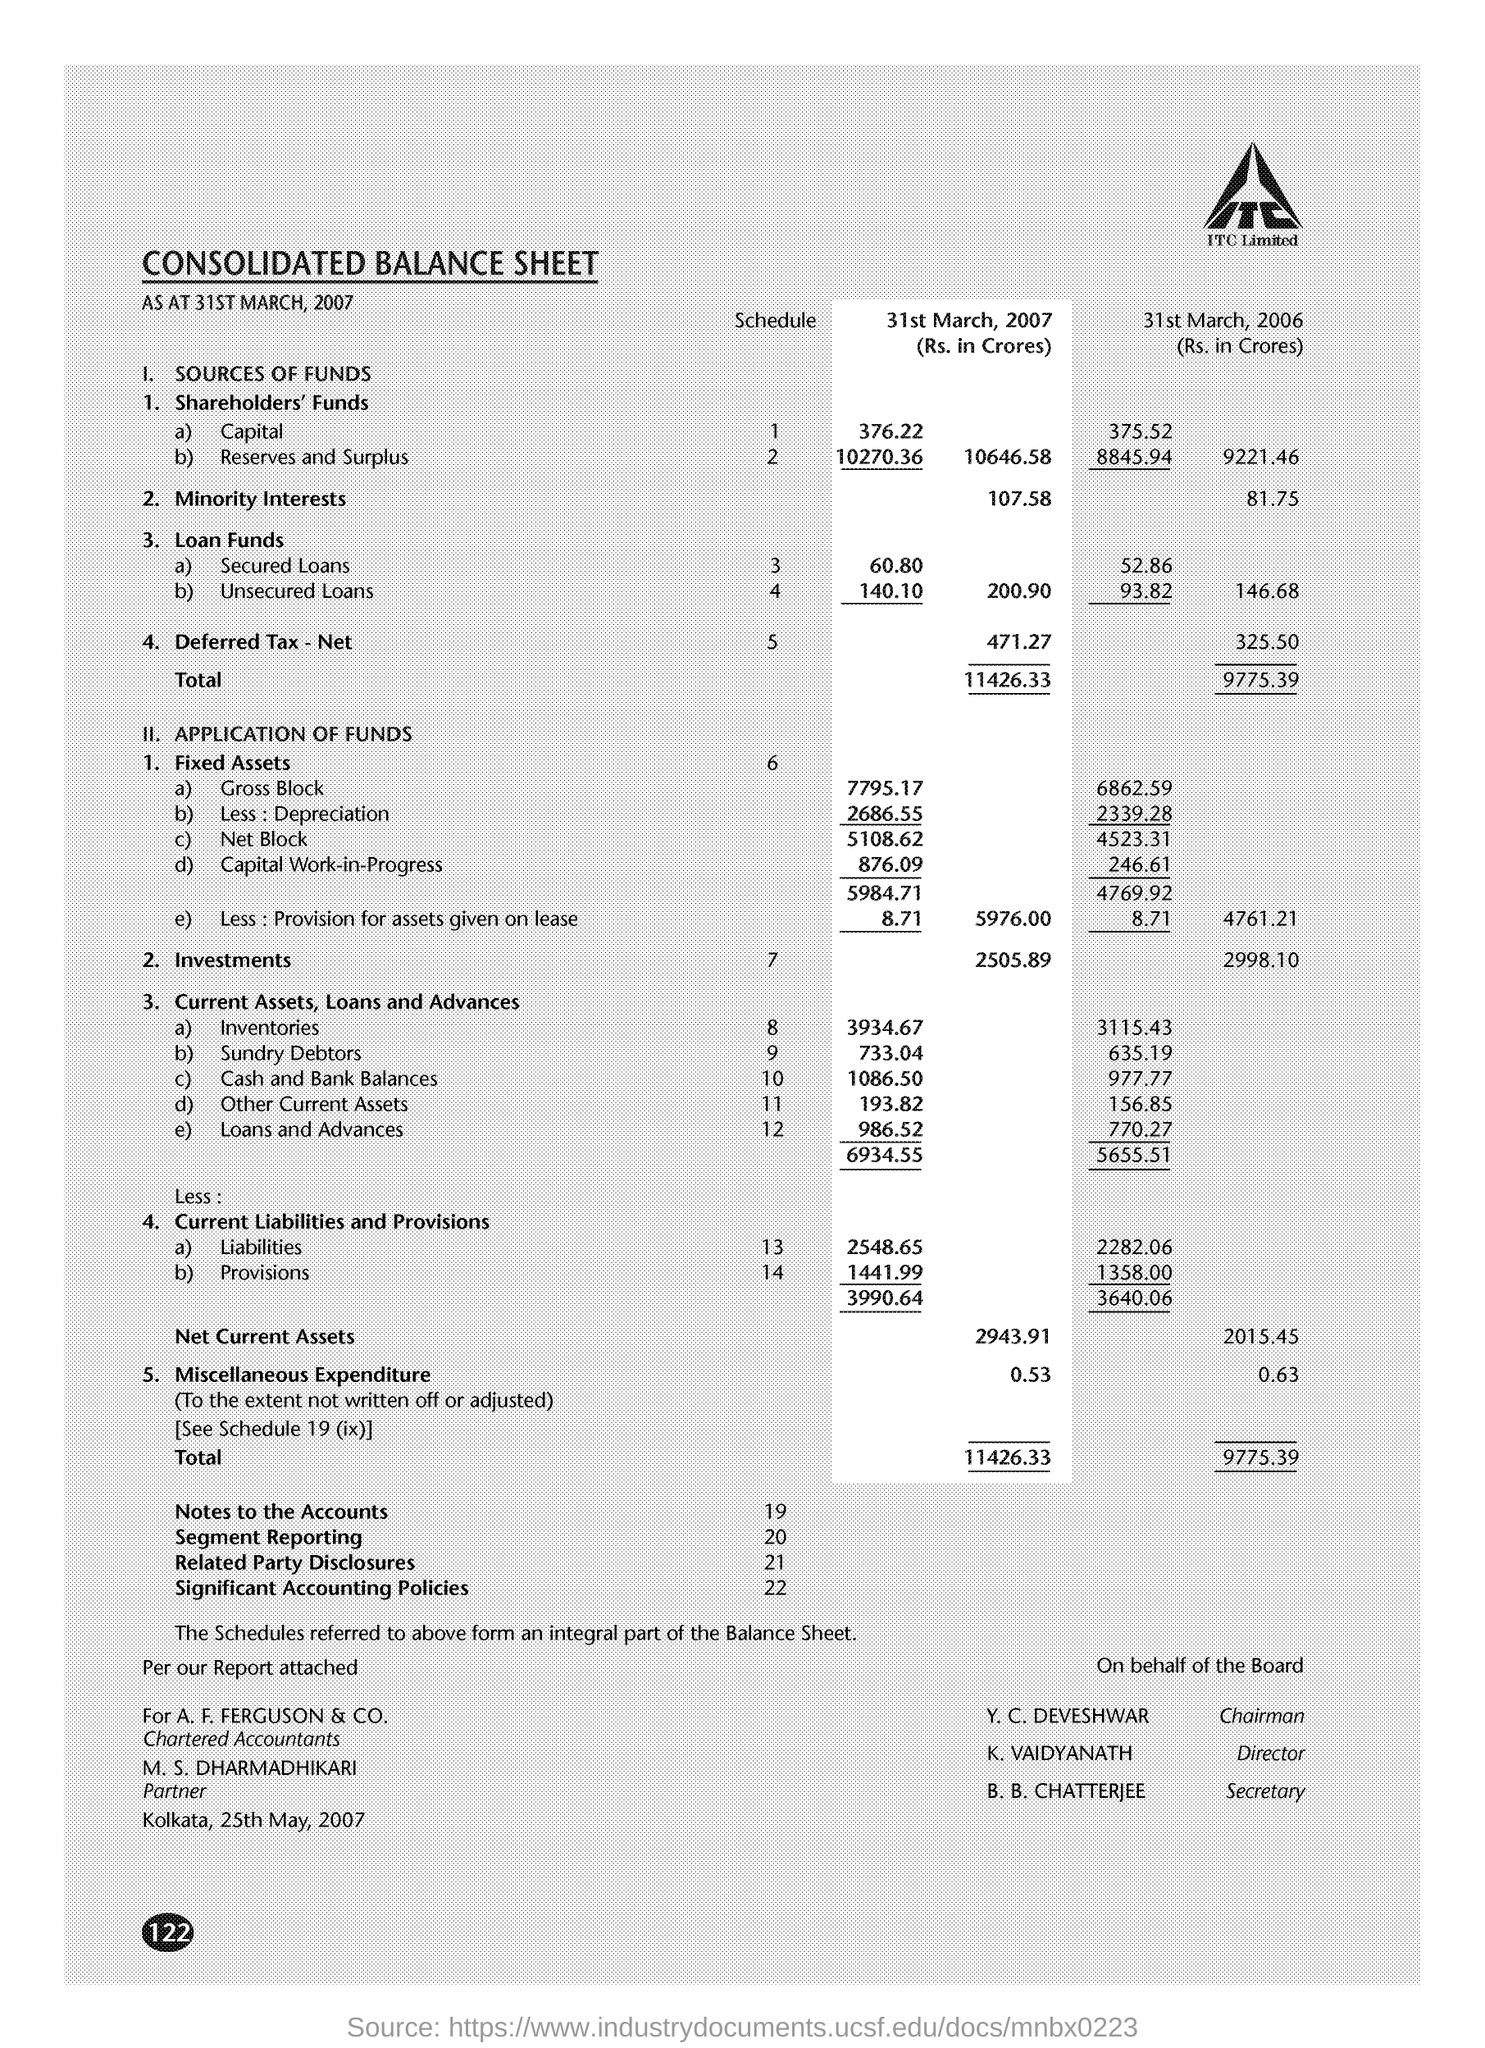What is the Title of the document?
Keep it short and to the point. Consolidated Balance Sheet. What is the place name on the document?
Provide a short and direct response. Kolkata. What is the Deferred Tax - Net for 31st March 2007?
Keep it short and to the point. 471.27. What is the Deferred Tax - Net for 31st March 2006?
Offer a terse response. 325.50. What are the Investments for 31st March 2006?
Provide a short and direct response. 2998.10. What are the Investments for 31st March 2007?
Your answer should be very brief. 2505.89. What are the Net Current Assets for 31st March 2006?
Your response must be concise. 2015.45. What are the Net Current Assets for 31st March 2007?
Offer a very short reply. 2943.91. Who is the Chairman?
Your answer should be compact. Y. C. Deveshwar. 